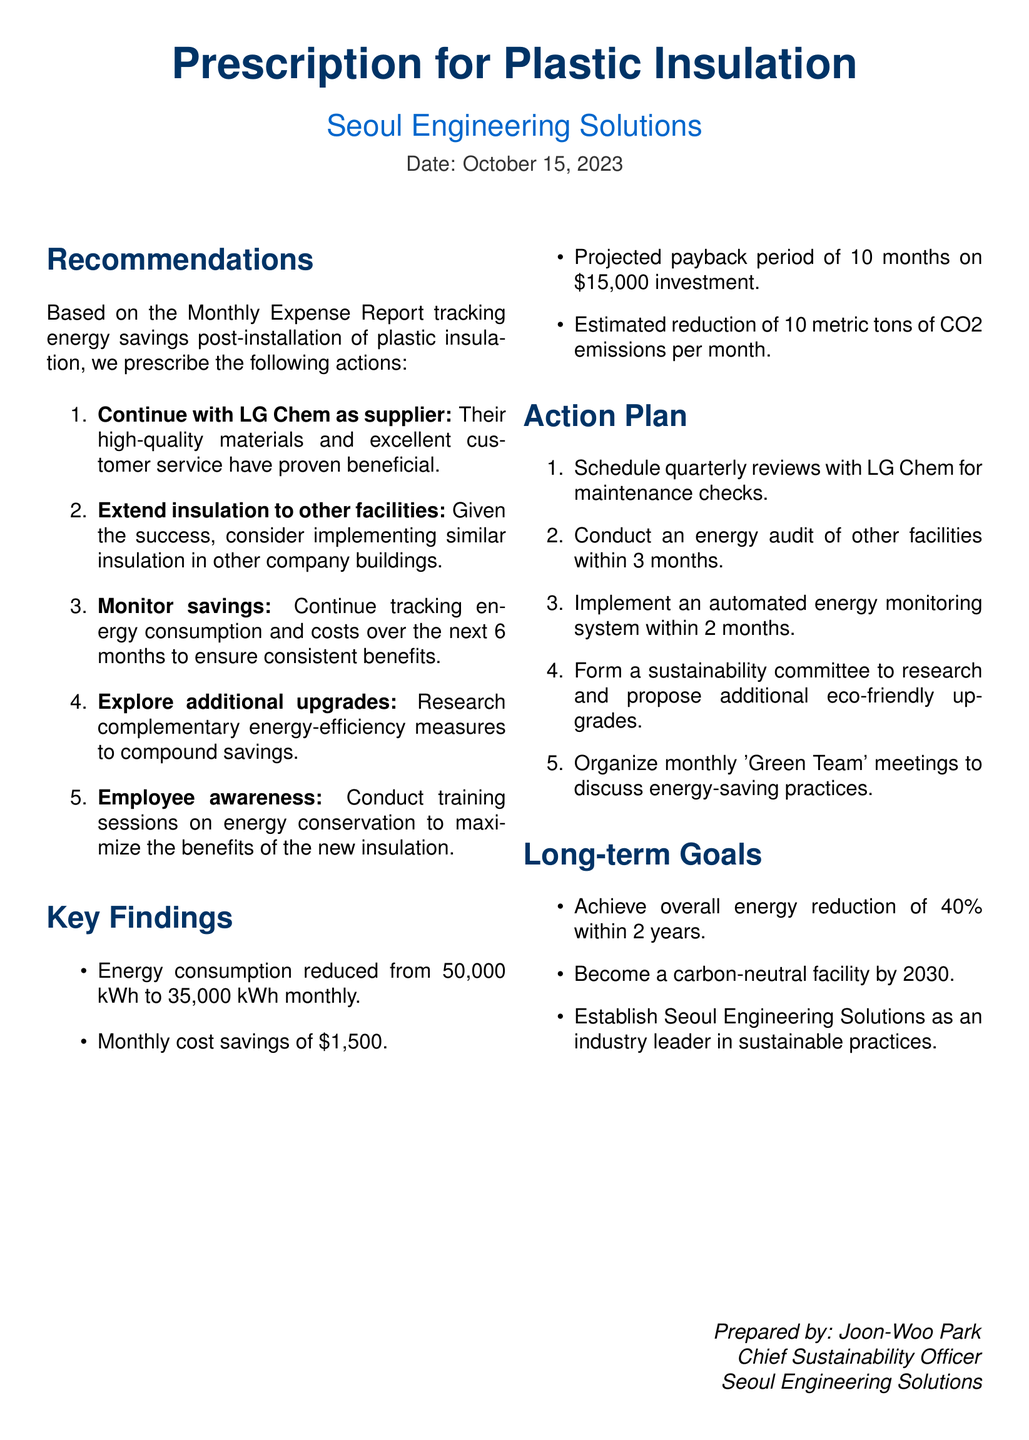What is the date of the document? The date of the document is specified clearly at the top of the document.
Answer: October 15, 2023 Who is the supplier recommended for continuation? The document highlights which supplier is preferred based on their materials and service.
Answer: LG Chem What was the reduced energy consumption after insulation installation? The monthly energy consumption figures are provided in the key findings section.
Answer: 35,000 kWh What is the projected payback period for the investment? The projected payback period is calculated based on the investment amount provided.
Answer: 10 months How much CO2 emissions are estimated to be reduced monthly? The document details the estimated reduction in CO2 emissions in the key findings.
Answer: 10 metric tons What is the overall energy reduction target within 2 years? The document specifies a target for overall energy reduction as a part of long-term goals.
Answer: 40% What is the planned duration for implementing an automated energy monitoring system? The action plan details the timeline for this particular implementation.
Answer: 2 months What periodic reviews are scheduled with the supplier? The action plan mentions the type of reviews planned with the supplier.
Answer: Quarterly reviews What is the monthly cost savings from the insulation? The amount saved monthly as a result of insulation is stated in the key findings.
Answer: $1,500 